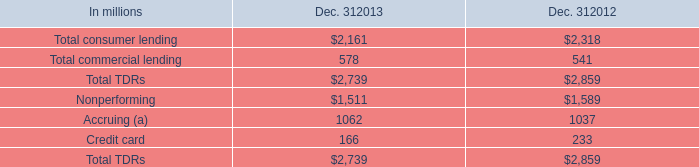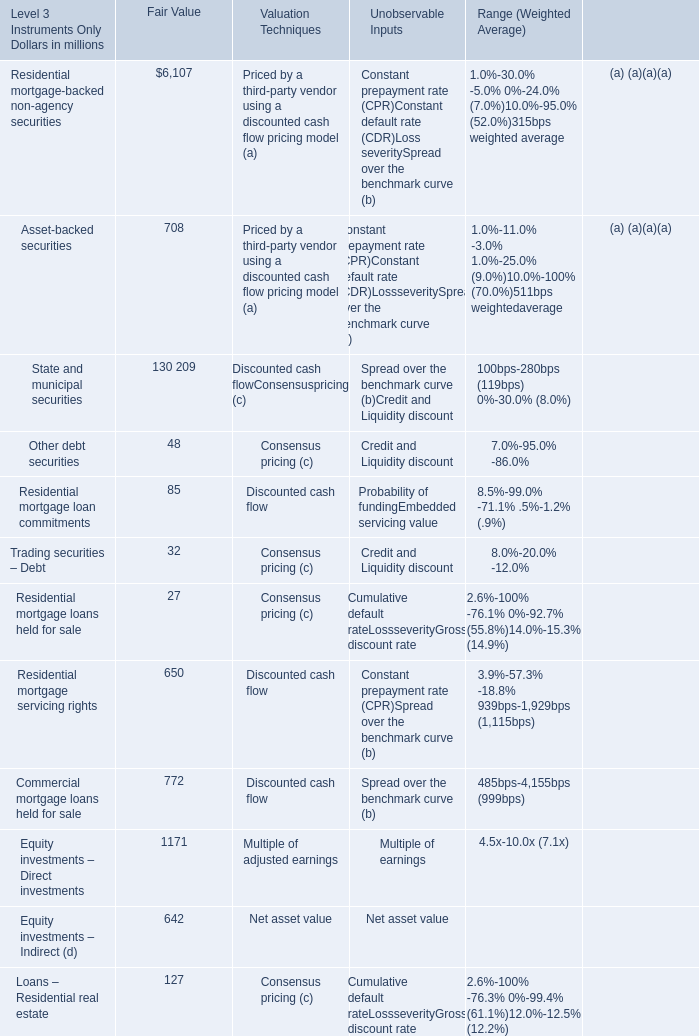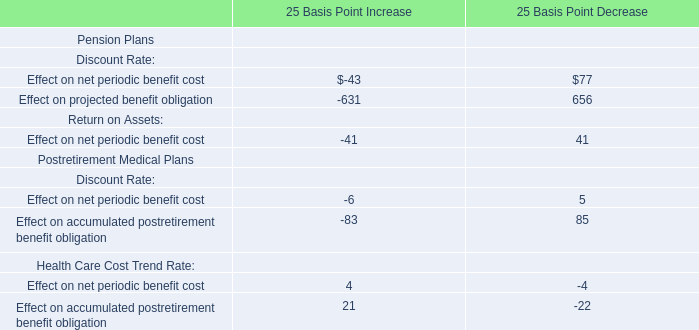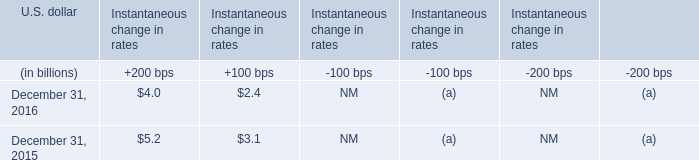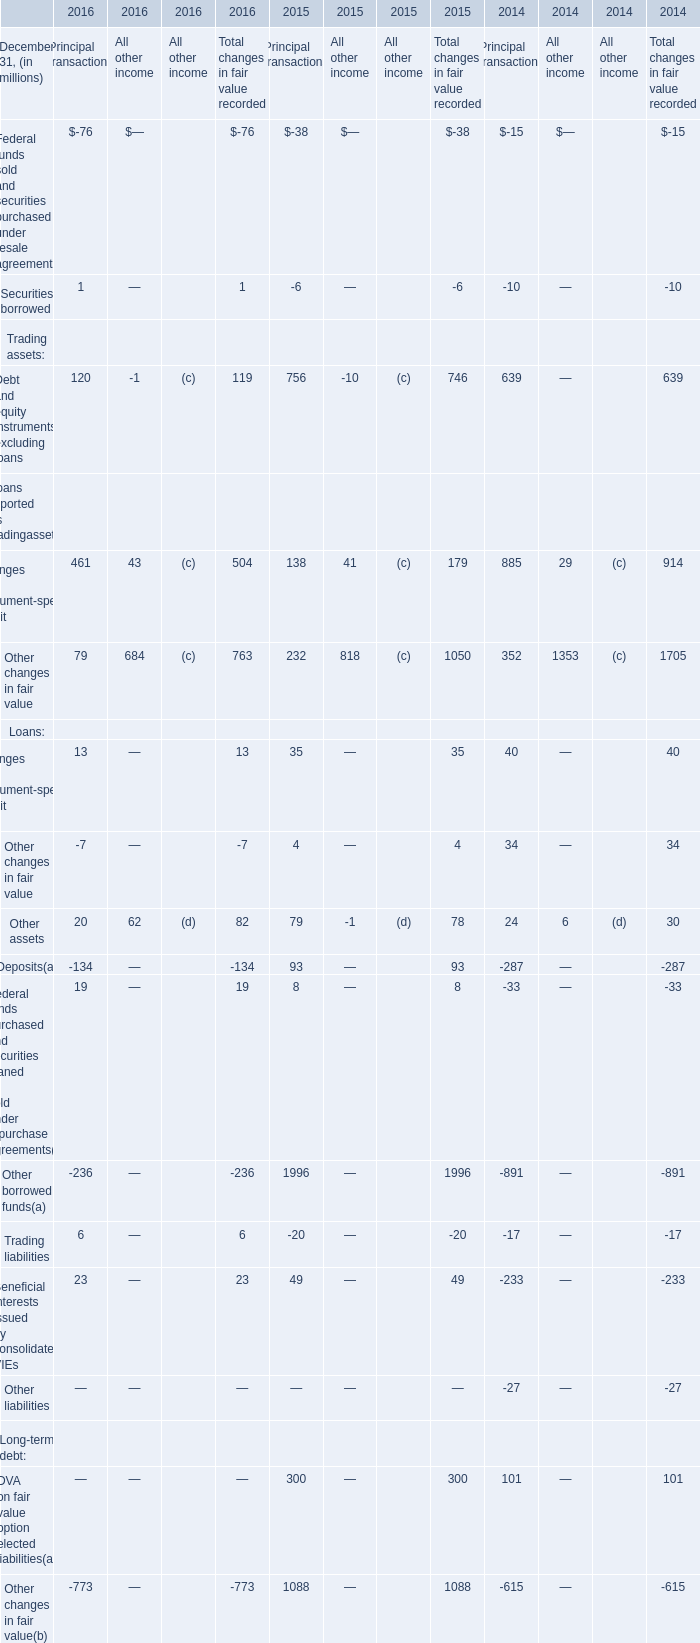In the year with lowest amount of Changes in instrument-specific credit risk, what's the increasing rate of Other changes in fair value? 
Computations: ((-7 - 4) / -7)
Answer: 1.57143. 